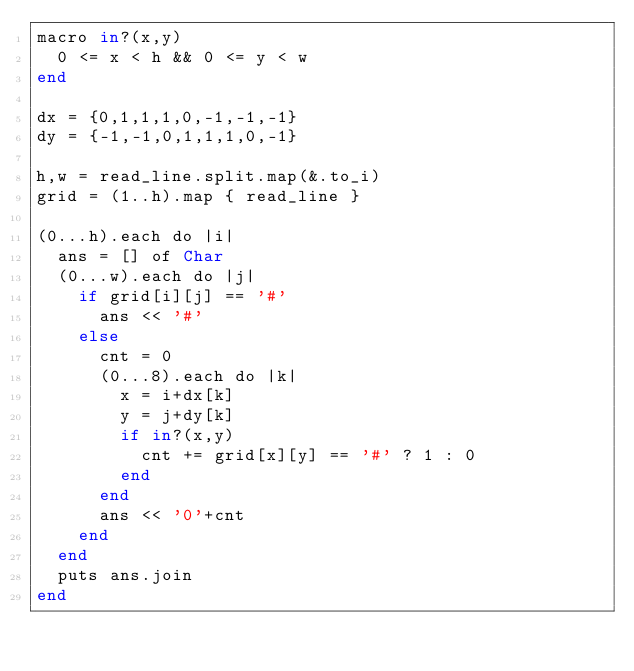<code> <loc_0><loc_0><loc_500><loc_500><_Crystal_>macro in?(x,y)
  0 <= x < h && 0 <= y < w
end

dx = {0,1,1,1,0,-1,-1,-1}
dy = {-1,-1,0,1,1,1,0,-1}

h,w = read_line.split.map(&.to_i)
grid = (1..h).map { read_line }

(0...h).each do |i|
  ans = [] of Char
  (0...w).each do |j|
    if grid[i][j] == '#'
      ans << '#'
    else
      cnt = 0
      (0...8).each do |k|
        x = i+dx[k]
        y = j+dy[k]
        if in?(x,y)
          cnt += grid[x][y] == '#' ? 1 : 0
        end
      end
      ans << '0'+cnt
    end
  end
  puts ans.join
end
</code> 